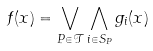Convert formula to latex. <formula><loc_0><loc_0><loc_500><loc_500>f ( x ) = \bigvee _ { P \in \mathcal { T } } \bigwedge _ { i \in S _ { P } } g _ { i } ( x )</formula> 